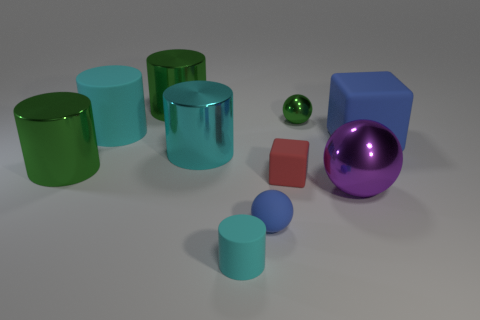How many cyan cylinders must be subtracted to get 1 cyan cylinders? 2 Subtract all green cylinders. How many cylinders are left? 3 Subtract all green cylinders. How many cylinders are left? 3 Subtract all purple blocks. How many cyan cylinders are left? 3 Subtract 2 cylinders. How many cylinders are left? 3 Subtract all spheres. How many objects are left? 7 Subtract all purple spheres. Subtract all yellow cylinders. How many spheres are left? 2 Subtract all tiny brown rubber objects. Subtract all small green balls. How many objects are left? 9 Add 5 big metallic cylinders. How many big metallic cylinders are left? 8 Add 2 rubber things. How many rubber things exist? 7 